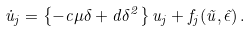<formula> <loc_0><loc_0><loc_500><loc_500>\dot { u } _ { j } = \left \{ - c \mu \delta + d \delta ^ { 2 } \right \} u _ { j } + f _ { j } ( \vec { u } , \vec { \epsilon } ) \, .</formula> 